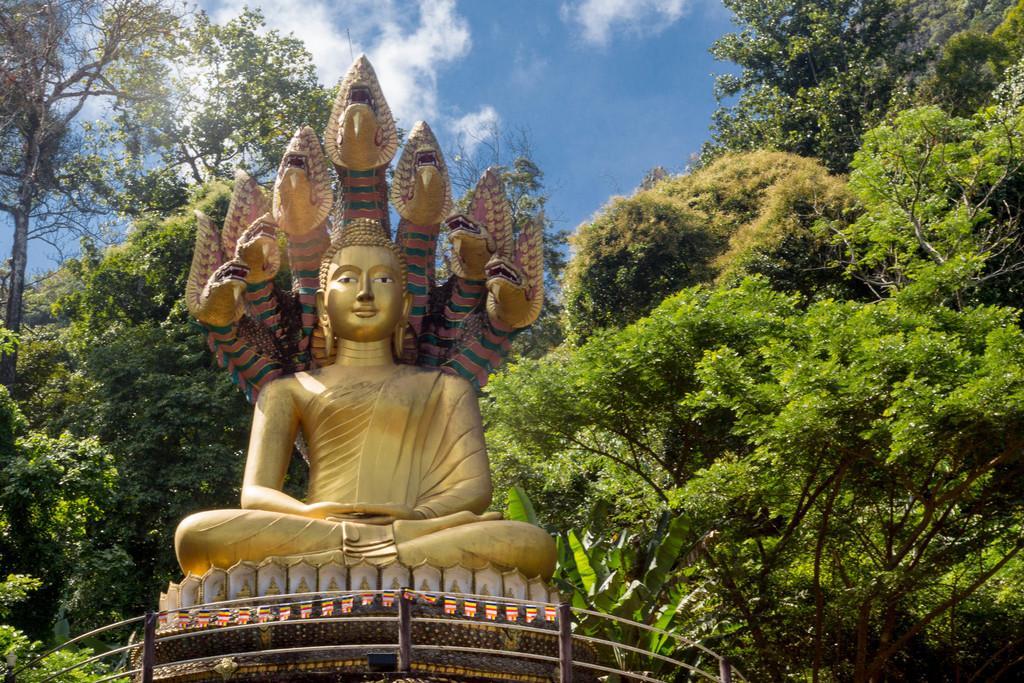Can you describe this image briefly? In the center of the image there is a statue. In the background of the image there are trees,sky. 